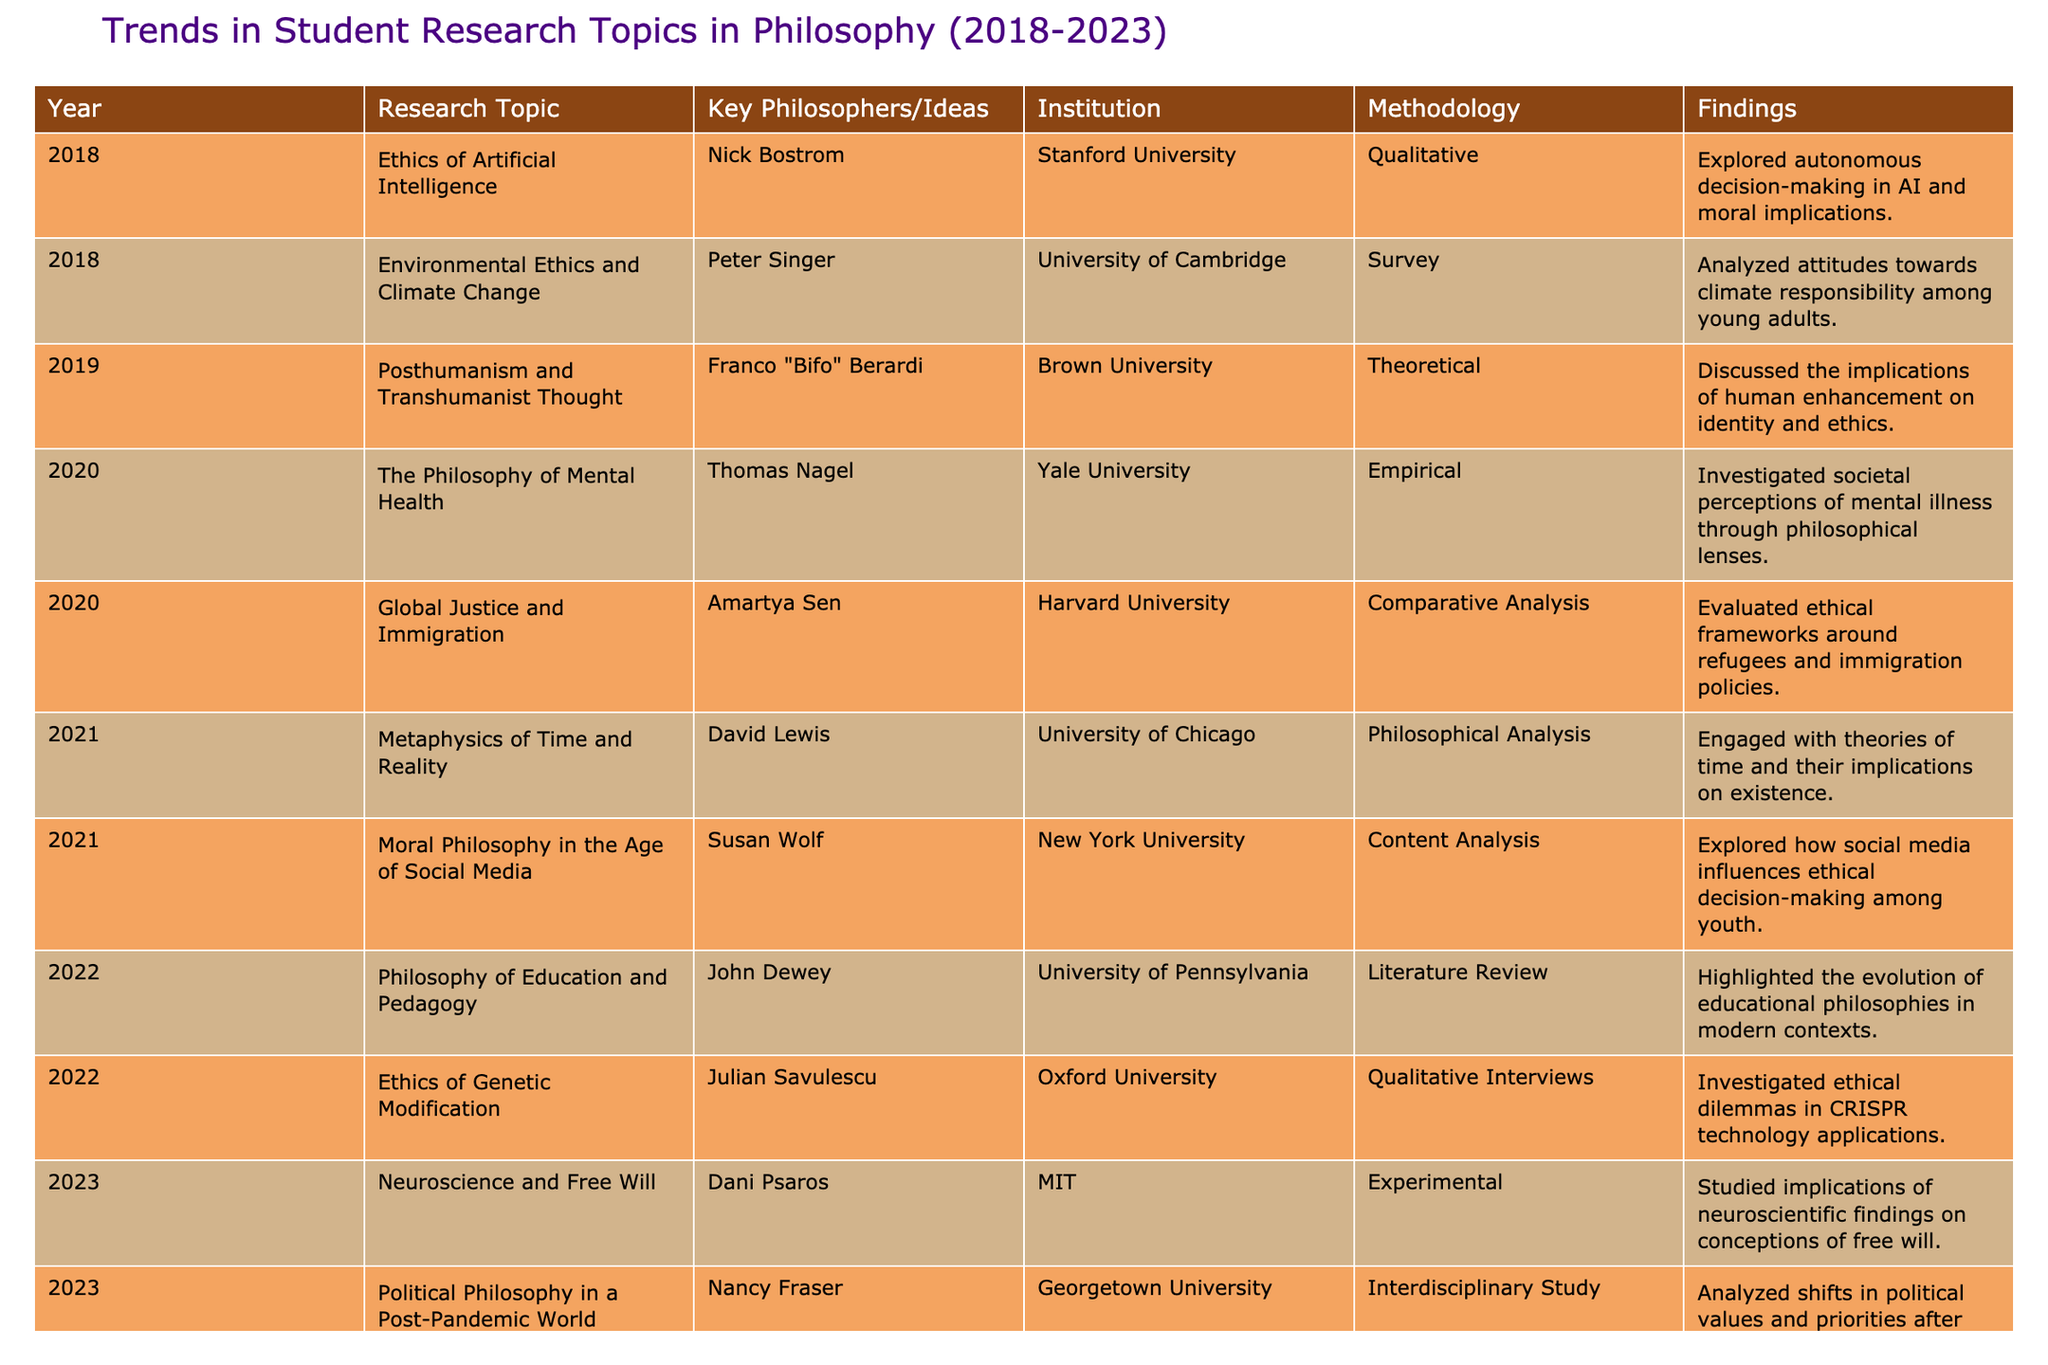What was the research topic in 2019? In the table, the year 2019 is associated with the topic "Posthumanism and Transhumanist Thought."
Answer: Posthumanism and Transhumanist Thought Which methodology was most commonly used in 2020? In 2020, there were two research topics with different methodologies: "The Philosophy of Mental Health" used Empirical and "Global Justice and Immigration" used Comparative Analysis. There is no single most common methodology in that year.
Answer: None How many research topics were focused on ethical dilemmas between 2018 and 2023? In the given data, the topics that focus on ethical dilemmas are "Ethics of Artificial Intelligence", "Environmental Ethics and Climate Change", "Ethics of Genetic Modification". Adding them together gives a total of three topics focusing on ethical dilemmas.
Answer: 3 Was there a research study that combined philosophy with scientific findings in 2023? Yes, the topic "Neuroscience and Free Will" in 2023 indicates a combination of philosophy with scientific findings regarding free will.
Answer: Yes How many total researchers are mentioned in the table? The table lists unique researchers linked to their respective topics from 2018 to 2023. Counting these names gives us a total of ten different researchers.
Answer: 10 In which years did the topics focus on social media's impact? The topic on this theme, "Moral Philosophy in the Age of Social Media," is in 2021, indicating that year is focused on social media's impact on moral philosophy.
Answer: 2021 Which institution conducted research on climate change and in what year? The University of Cambridge conducted research on "Environmental Ethics and Climate Change" in the year 2018.
Answer: University of Cambridge, 2018 What trend can be seen in the progression of topics from 2018 to 2023? The topics from 2018 to 2023 indicate an increasing focus on modern dilemmas and intersections with technology, like AI ethics and neuroscience, reflecting contemporary issues.
Answer: Increasing focus on modern dilemmas and technology How many different methodologies were used across all years? The methodologies listed are Qualitative, Survey, Theoretical, Empirical, Comparative Analysis, Philosophical Analysis, Content Analysis, Literature Review, Qualitative Interviews, and Experimental. Counting these distinct types gives a total of ten methodologies.
Answer: 10 What is the common theme found in the topics from 2022 compared to earlier years? In 2022, the topics "Philosophy of Education and Pedagogy" and "Ethics of Genetic Modification" show a trend toward ethical implications in education and technology, differing from the primarily ethical or theoretical focus in previous years.
Answer: Ethical implications in education and technology 